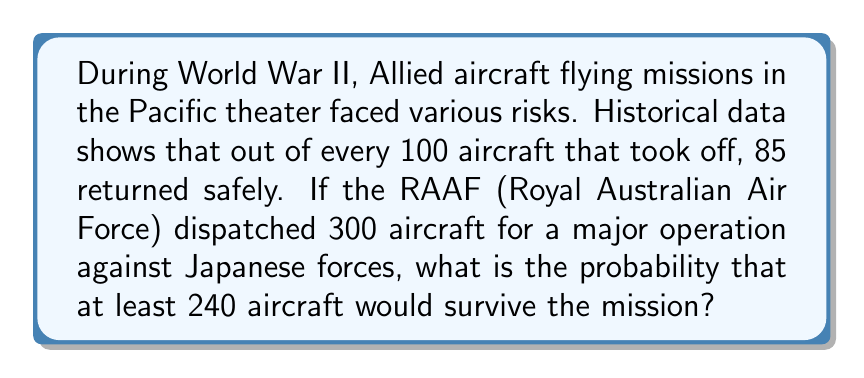Teach me how to tackle this problem. Let's approach this step-by-step:

1) First, we need to identify the probability distribution. This scenario follows a binomial distribution because:
   - There are a fixed number of trials (300 aircraft)
   - Each trial has two possible outcomes (survive or not survive)
   - The probability of success (survival) is constant for each trial
   - The trials are independent

2) We know:
   - $n = 300$ (number of aircraft)
   - $p = 0.85$ (probability of survival for each aircraft)
   - We want to find $P(X \geq 240)$, where $X$ is the number of surviving aircraft

3) For large $n$, we can approximate the binomial distribution with a normal distribution:
   $X \sim N(\mu, \sigma^2)$, where:
   $\mu = np = 300 * 0.85 = 255$
   $\sigma^2 = np(1-p) = 300 * 0.85 * 0.15 = 38.25$
   $\sigma = \sqrt{38.25} \approx 6.18$

4) We need to find $P(X \geq 240)$. First, we calculate the z-score:
   $z = \frac{240 - 255}{6.18} \approx -2.43$

5) Now, we need to find $P(Z \geq -2.43)$. Using a standard normal table or calculator:
   $P(Z \geq -2.43) = 1 - P(Z < -2.43) \approx 1 - 0.0075 = 0.9925$

Therefore, the probability that at least 240 out of 300 aircraft would survive the mission is approximately 0.9925 or 99.25%.
Answer: $0.9925$ or $99.25\%$ 